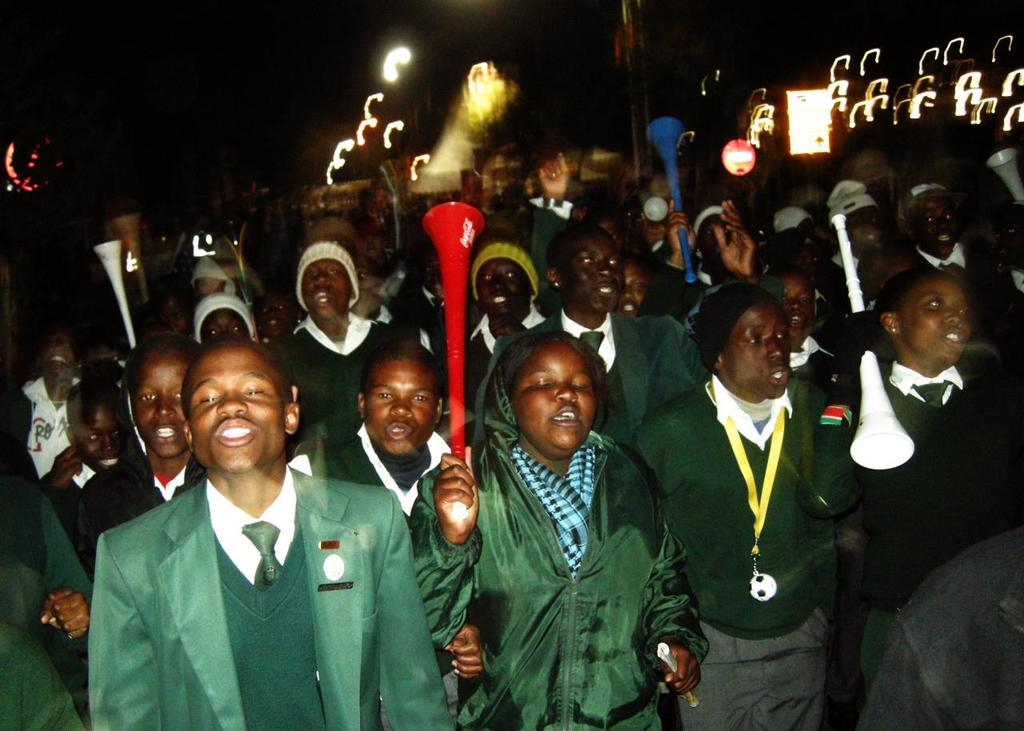How many people are in the image? There is a group of people in the image, but the exact number is not specified. What are the people holding in the image? The people are holding sticks in the image. What might the people be doing with the sticks? The people appear to be talking, so they might be using the sticks for a conversation or activity. What can be seen in the background of the image? There are lights and objects in the background of the image. What type of circle is visible in the image? There is no circle present in the image. Is there a tent in the image? There is no tent present in the image. 